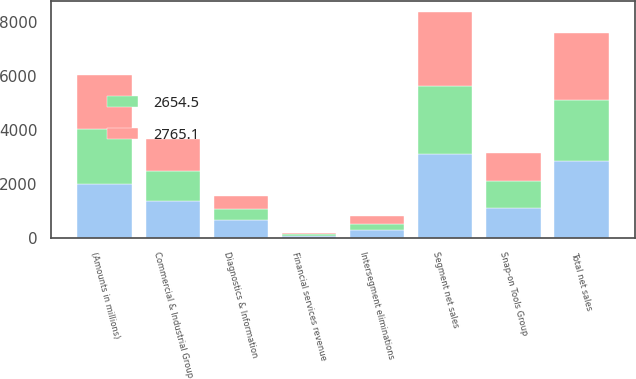Convert chart to OTSL. <chart><loc_0><loc_0><loc_500><loc_500><stacked_bar_chart><ecel><fcel>(Amounts in millions)<fcel>Commercial & Industrial Group<fcel>Snap-on Tools Group<fcel>Diagnostics & Information<fcel>Segment net sales<fcel>Intersegment eliminations<fcel>Total net sales<fcel>Financial services revenue<nl><fcel>nan<fcel>2007<fcel>1350.6<fcel>1107.7<fcel>650.6<fcel>3108.9<fcel>267.7<fcel>2841.2<fcel>63<nl><fcel>2765.1<fcel>2006<fcel>1192<fcel>1025<fcel>506.2<fcel>2723.2<fcel>268.1<fcel>2455.1<fcel>49<nl><fcel>2654.5<fcel>2005<fcel>1129.2<fcel>994.5<fcel>405.1<fcel>2528.8<fcel>247.8<fcel>2281<fcel>53.6<nl></chart> 